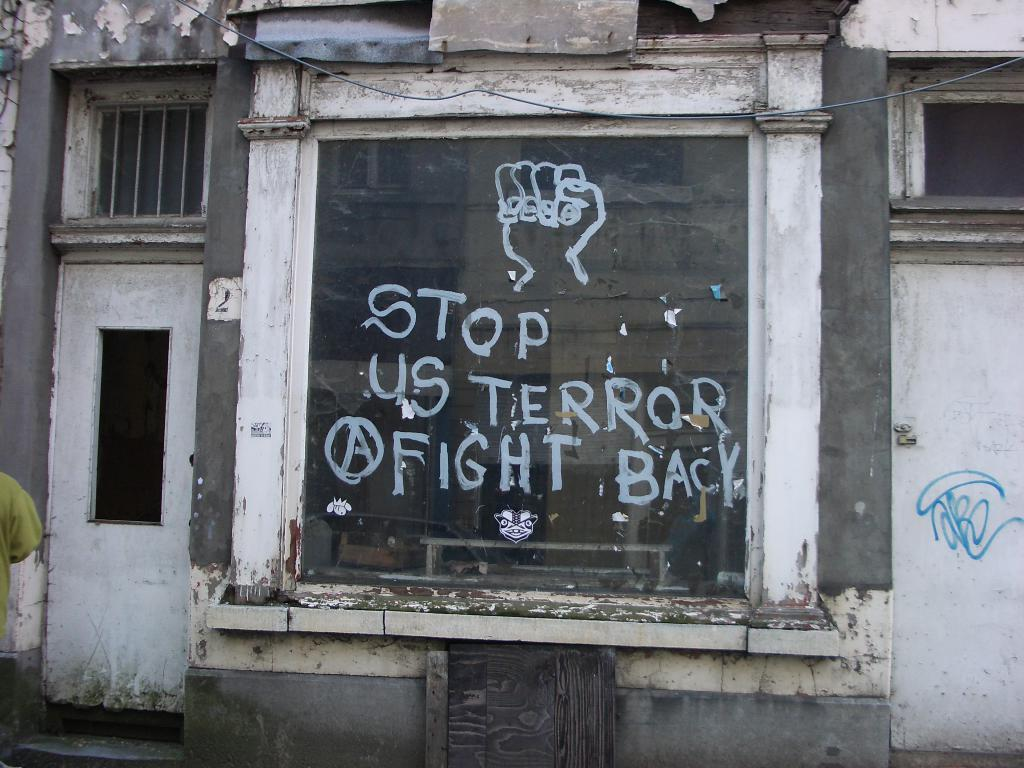What is the main subject of the image? The main subject of the image is a building. What architectural feature can be seen on the building? The building has windows. What type of entrance is visible in the image? There is a glass door in the image. What is written or displayed on the glass door? Letters are written on the glass door. What is the purpose of the smoke coming out of the building in the image? There is no smoke coming out of the building in the image. What religion is practiced inside the building in the image? The image does not provide any information about the religion practiced inside the building. 